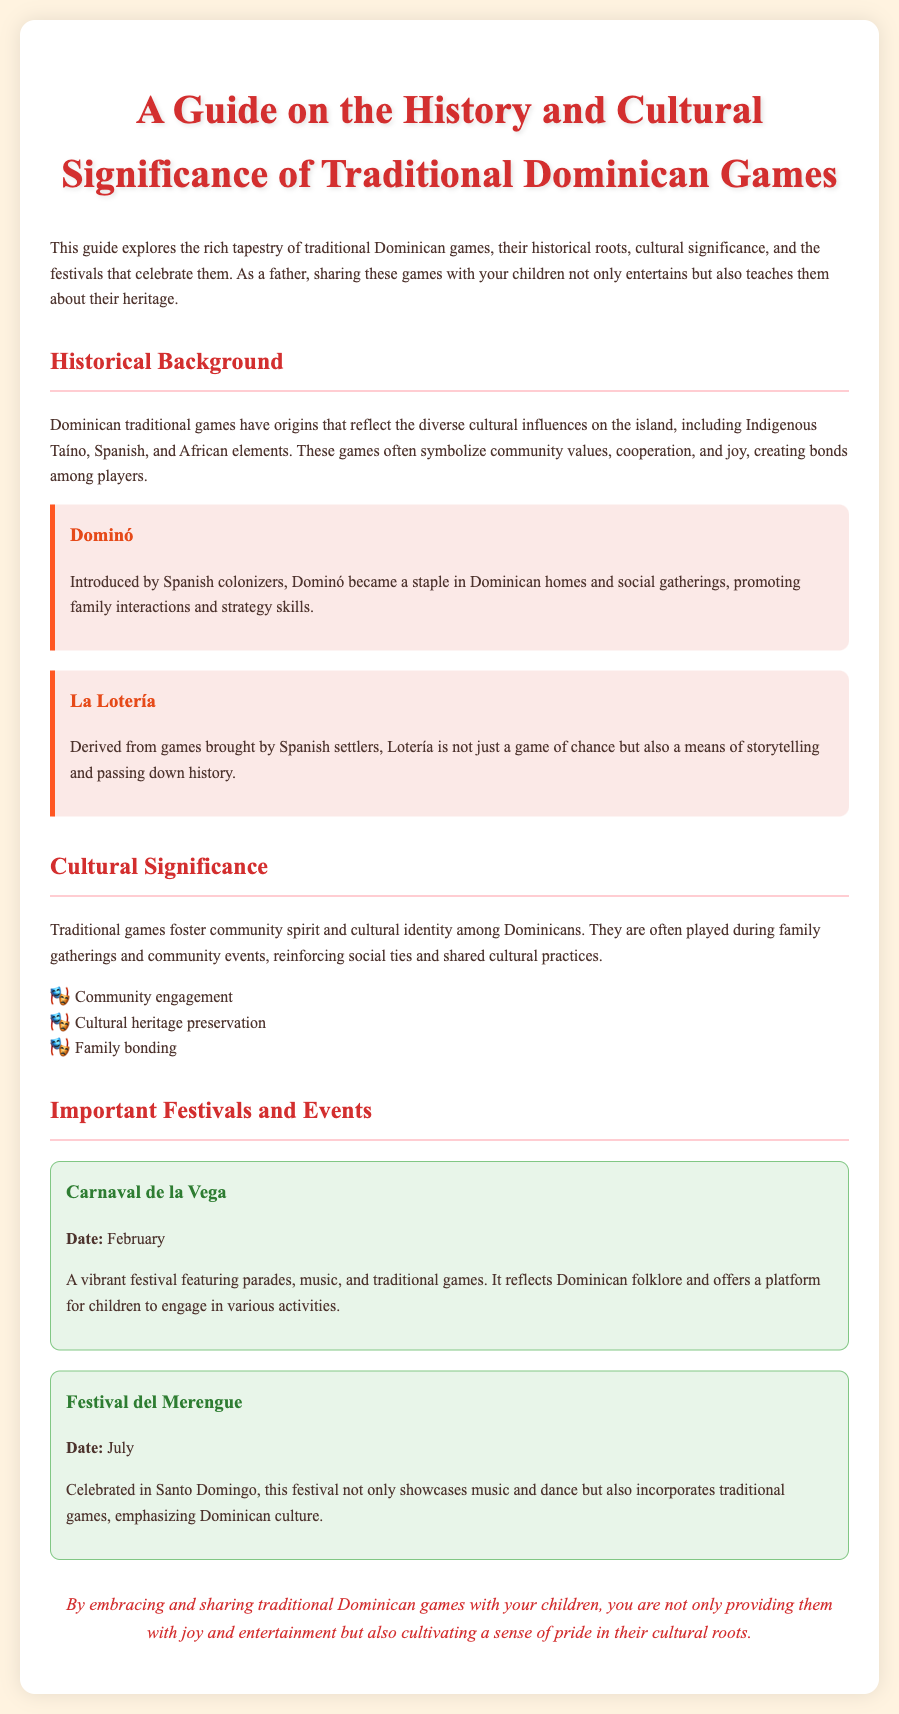What is the title of the guide? The title of the guide is stated clearly at the top of the document.
Answer: A Guide on the History and Cultural Significance of Traditional Dominican Games What is the first traditional game mentioned? The document lists traditional games in separate sections, beginning with Dominó.
Answer: Dominó What cultural elements influence Dominican traditional games? The document highlights the influences that shape Dominican games and lists them in the historical background.
Answer: Indigenous Taíno, Spanish, and African elements What is celebrated during Carnaval de la Vega? The document describes this festival, including the nature of the events that take place.
Answer: Parades, music, and traditional games In which month is the Festival del Merengue celebrated? The document provides the date of the festival, highlighting its timing during the year.
Answer: July What is one benefit of traditional games according to the document? The document lists benefits of traditional games, including those related to social connections.
Answer: Family bonding What are traditional games often a means of? This question addresses the significance of games in sharing cultural aspects, as stated in the guide.
Answer: Storytelling What festival provides a platform for children to engage in activities? The document specifies a festival that emphasizes children's participation in various ways.
Answer: Carnaval de la Vega 